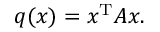<formula> <loc_0><loc_0><loc_500><loc_500>q ( x ) = x ^ { T } A x .</formula> 